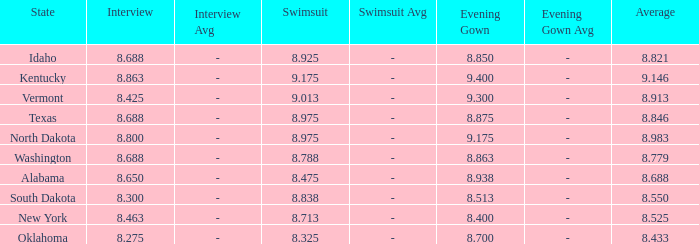Parse the table in full. {'header': ['State', 'Interview', 'Interview Avg', 'Swimsuit', 'Swimsuit Avg', 'Evening Gown', 'Evening Gown Avg', 'Average'], 'rows': [['Idaho', '8.688', '-', '8.925', '-', '8.850', '-', '8.821'], ['Kentucky', '8.863', '-', '9.175', '-', '9.400', '-', '9.146'], ['Vermont', '8.425', '-', '9.013', '-', '9.300', '-', '8.913'], ['Texas', '8.688', '-', '8.975', '-', '8.875', '-', '8.846'], ['North Dakota', '8.800', '-', '8.975', '-', '9.175', '-', '8.983'], ['Washington', '8.688', '-', '8.788', '-', '8.863', '-', '8.779'], ['Alabama', '8.650', '-', '8.475', '-', '8.938', '-', '8.688'], ['South Dakota', '8.300', '-', '8.838', '-', '8.513', '-', '8.550'], ['New York', '8.463', '-', '8.713', '-', '8.400', '-', '8.525'], ['Oklahoma', '8.275', '-', '8.325', '-', '8.700', '-', '8.433']]} Who had the lowest interview score from South Dakota with an evening gown less than 8.513? None. 